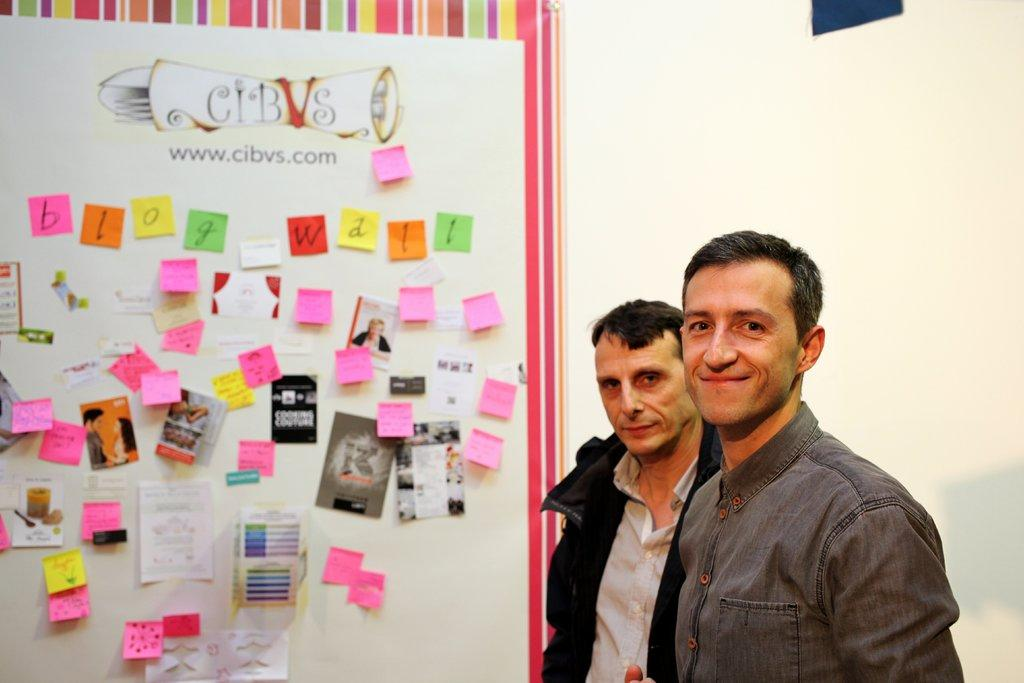How many people are in the image? There are two people in the image. What are the two people doing? The two people are posing for a picture. What can be seen on the wall in the image? There is a poster visible in the image. Can you describe the poster? The poster consists of sticky notes and includes images and some text. What historical event is being discussed on the poster? The poster does not depict or discuss any historical events; it consists of sticky notes with images and text. 